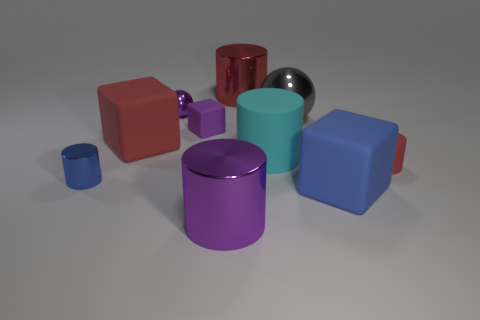What size is the sphere that is the same color as the small cube?
Ensure brevity in your answer.  Small. What shape is the tiny object that is the same color as the small metallic sphere?
Give a very brief answer. Cube. Is there anything else that has the same color as the small rubber block?
Make the answer very short. Yes. There is a small metal ball; does it have the same color as the thing that is in front of the blue rubber cube?
Keep it short and to the point. Yes. Are there an equal number of gray balls on the left side of the tiny sphere and tiny blue metallic cylinders on the right side of the cyan thing?
Provide a short and direct response. Yes. How many other things are there of the same size as the purple matte thing?
Your answer should be very brief. 3. How big is the blue shiny object?
Your answer should be very brief. Small. Is the material of the purple block the same as the red object that is behind the tiny purple metal thing?
Provide a short and direct response. No. Are there any other things of the same shape as the big red matte object?
Provide a succinct answer. Yes. There is a gray object that is the same size as the purple cylinder; what is its material?
Ensure brevity in your answer.  Metal. 